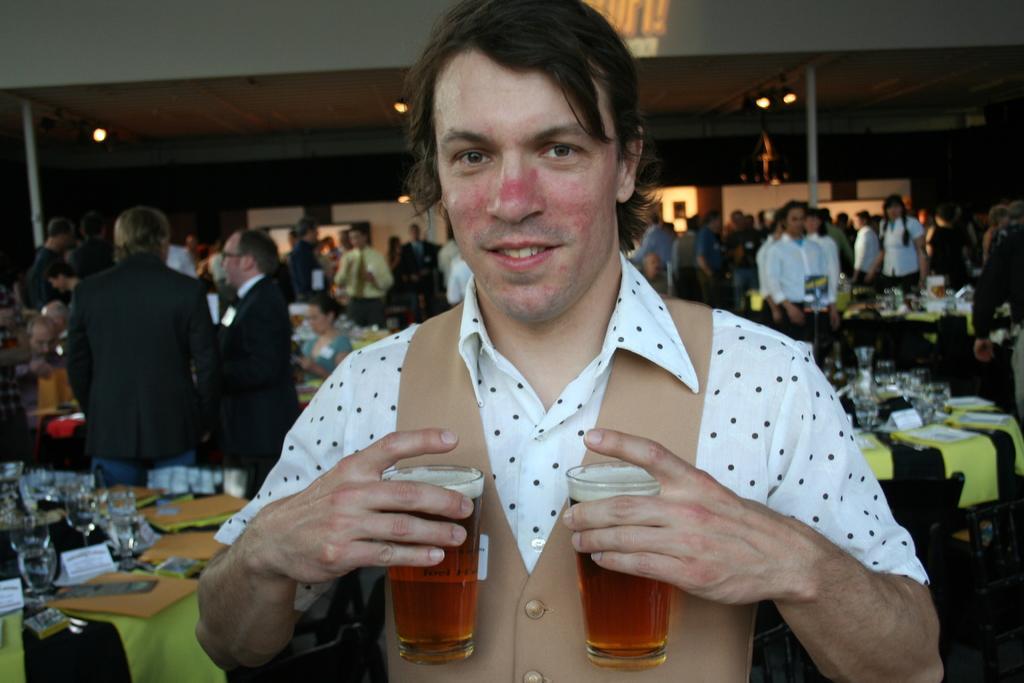How would you summarize this image in a sentence or two? In this image I can see a man is holding two glasses and also I can see smile on his face. In the background I can see number of people are standing and here I can see tables and number of glasses on every table. 